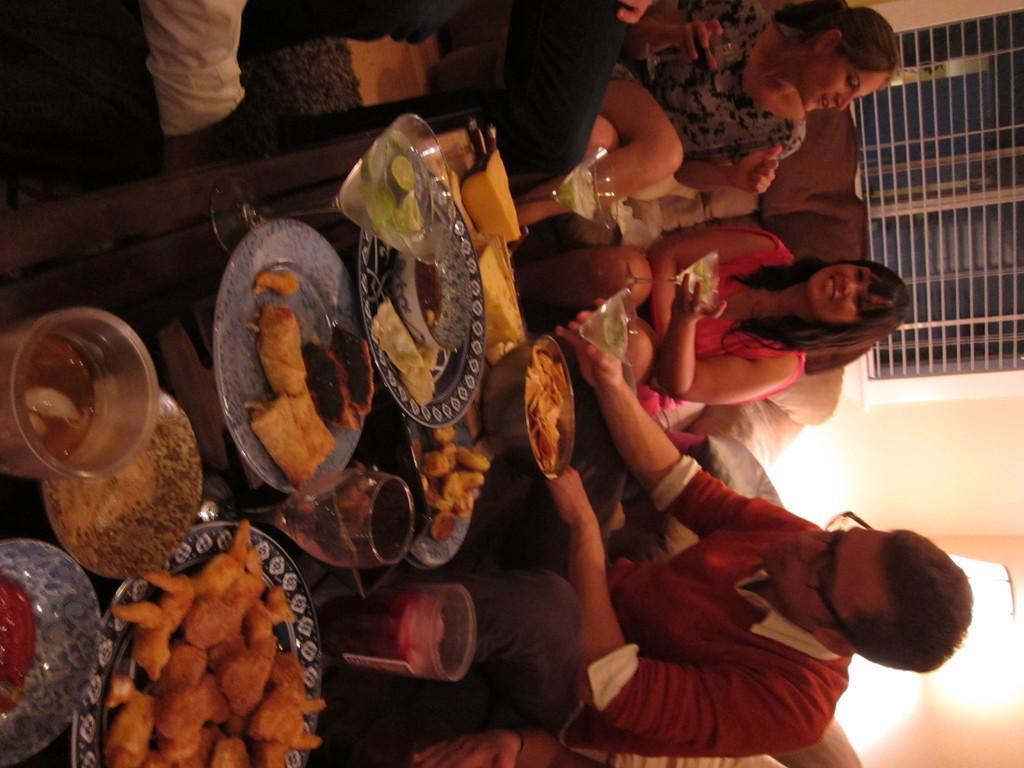Please provide a concise description of this image. In this picture there is a dining table in the center of the image, on which there are glasses and food items on it, there are people those who are sitting around it and there are windows and a lamp in the background area of the image. 